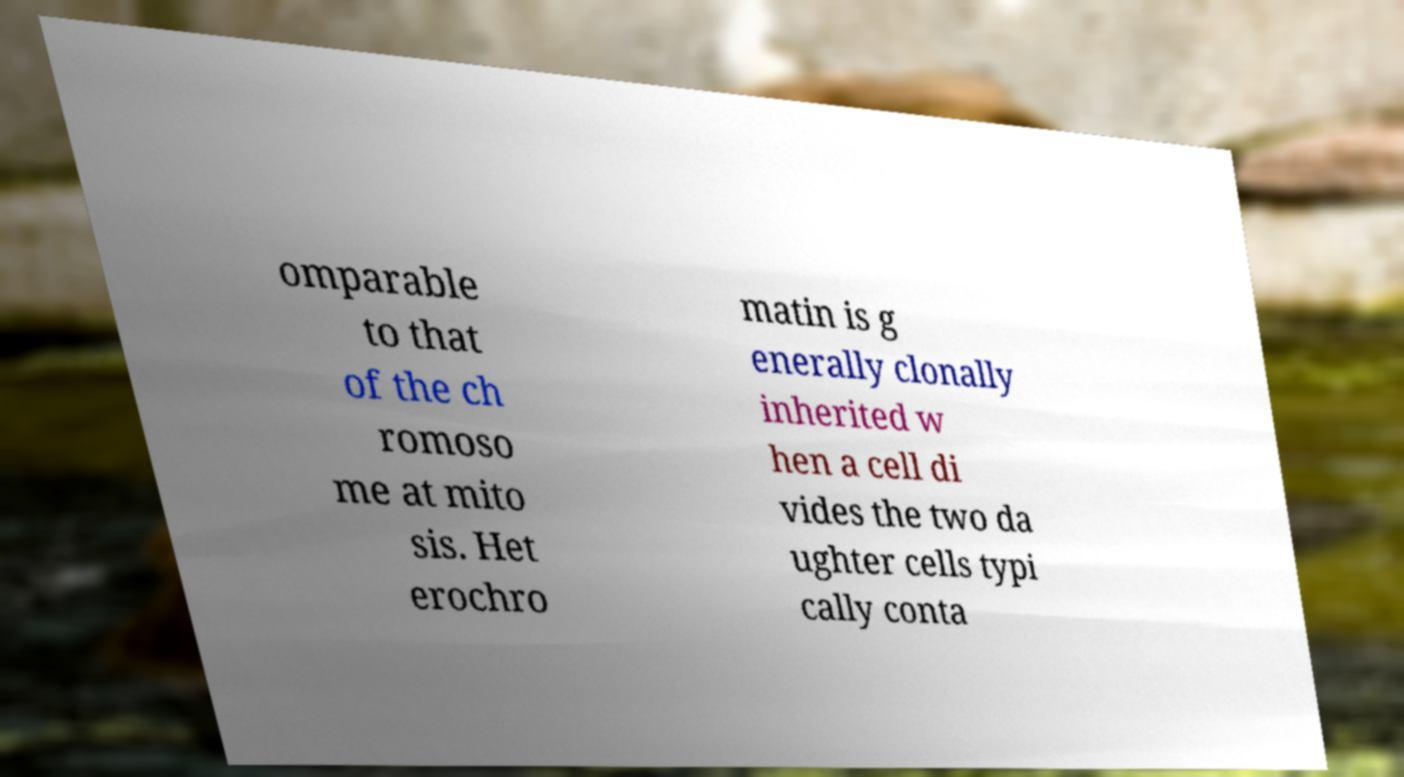Could you assist in decoding the text presented in this image and type it out clearly? omparable to that of the ch romoso me at mito sis. Het erochro matin is g enerally clonally inherited w hen a cell di vides the two da ughter cells typi cally conta 